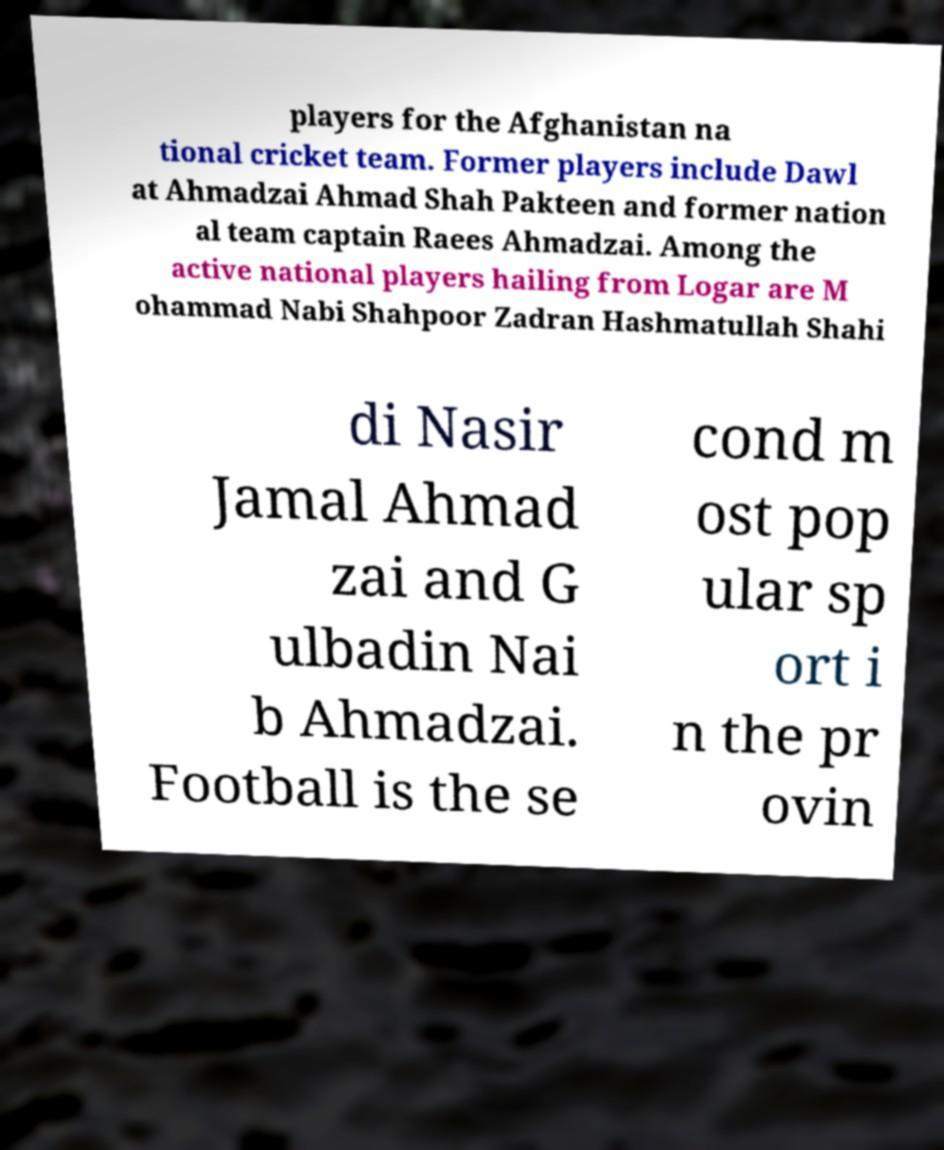For documentation purposes, I need the text within this image transcribed. Could you provide that? players for the Afghanistan na tional cricket team. Former players include Dawl at Ahmadzai Ahmad Shah Pakteen and former nation al team captain Raees Ahmadzai. Among the active national players hailing from Logar are M ohammad Nabi Shahpoor Zadran Hashmatullah Shahi di Nasir Jamal Ahmad zai and G ulbadin Nai b Ahmadzai. Football is the se cond m ost pop ular sp ort i n the pr ovin 